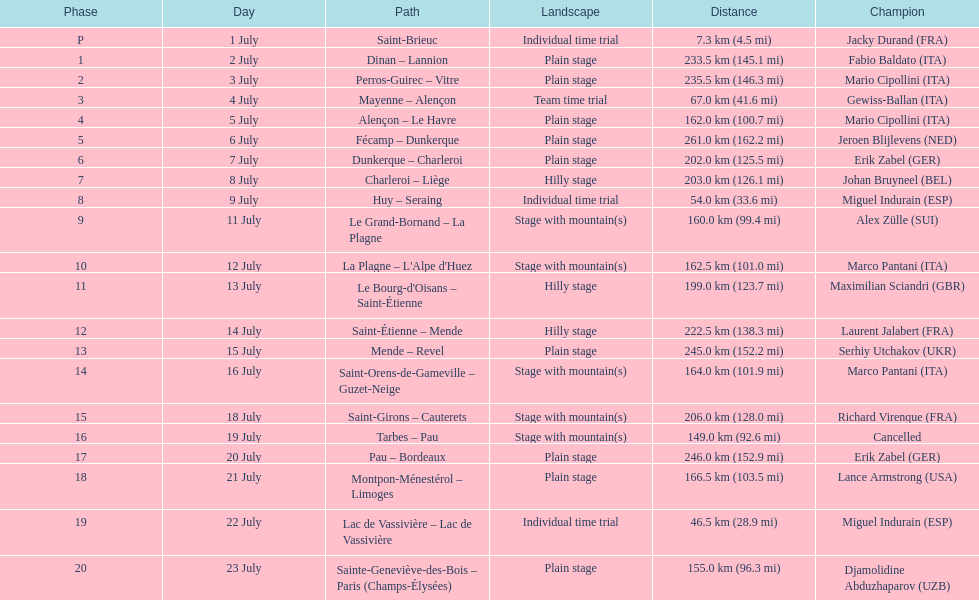How much longer is the 20th tour de france stage than the 19th? 108.5 km. 